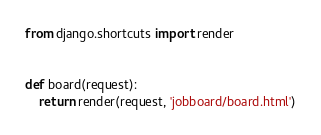<code> <loc_0><loc_0><loc_500><loc_500><_Python_>from django.shortcuts import render


def board(request):
    return render(request, 'jobboard/board.html')
</code> 